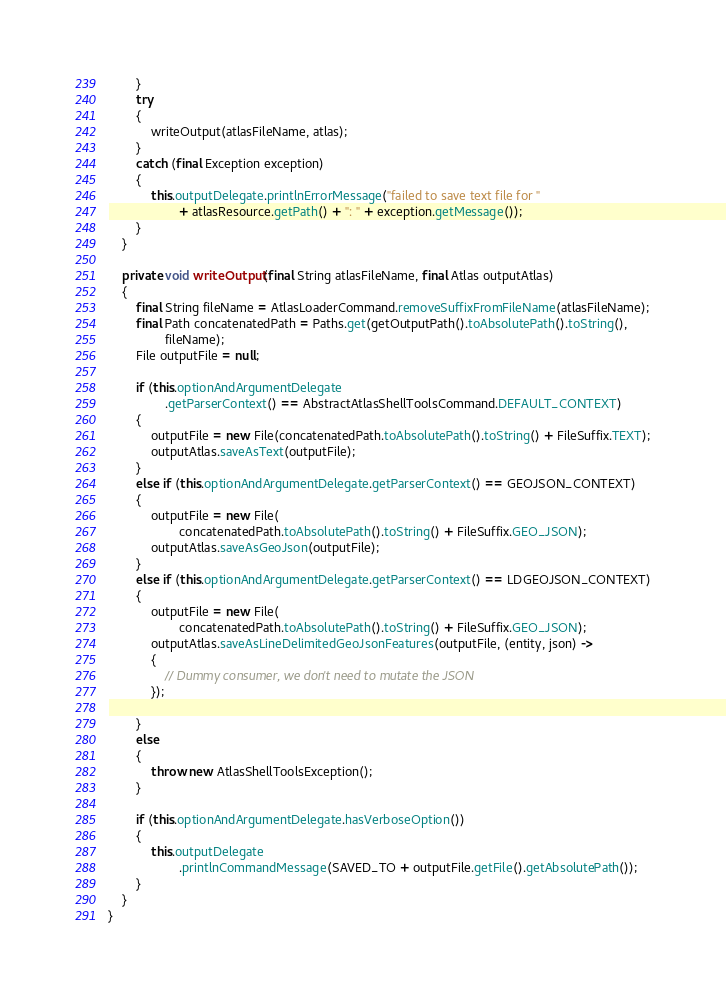Convert code to text. <code><loc_0><loc_0><loc_500><loc_500><_Java_>        }
        try
        {
            writeOutput(atlasFileName, atlas);
        }
        catch (final Exception exception)
        {
            this.outputDelegate.printlnErrorMessage("failed to save text file for "
                    + atlasResource.getPath() + ": " + exception.getMessage());
        }
    }

    private void writeOutput(final String atlasFileName, final Atlas outputAtlas)
    {
        final String fileName = AtlasLoaderCommand.removeSuffixFromFileName(atlasFileName);
        final Path concatenatedPath = Paths.get(getOutputPath().toAbsolutePath().toString(),
                fileName);
        File outputFile = null;

        if (this.optionAndArgumentDelegate
                .getParserContext() == AbstractAtlasShellToolsCommand.DEFAULT_CONTEXT)
        {
            outputFile = new File(concatenatedPath.toAbsolutePath().toString() + FileSuffix.TEXT);
            outputAtlas.saveAsText(outputFile);
        }
        else if (this.optionAndArgumentDelegate.getParserContext() == GEOJSON_CONTEXT)
        {
            outputFile = new File(
                    concatenatedPath.toAbsolutePath().toString() + FileSuffix.GEO_JSON);
            outputAtlas.saveAsGeoJson(outputFile);
        }
        else if (this.optionAndArgumentDelegate.getParserContext() == LDGEOJSON_CONTEXT)
        {
            outputFile = new File(
                    concatenatedPath.toAbsolutePath().toString() + FileSuffix.GEO_JSON);
            outputAtlas.saveAsLineDelimitedGeoJsonFeatures(outputFile, (entity, json) ->
            {
                // Dummy consumer, we don't need to mutate the JSON
            });

        }
        else
        {
            throw new AtlasShellToolsException();
        }

        if (this.optionAndArgumentDelegate.hasVerboseOption())
        {
            this.outputDelegate
                    .printlnCommandMessage(SAVED_TO + outputFile.getFile().getAbsolutePath());
        }
    }
}
</code> 